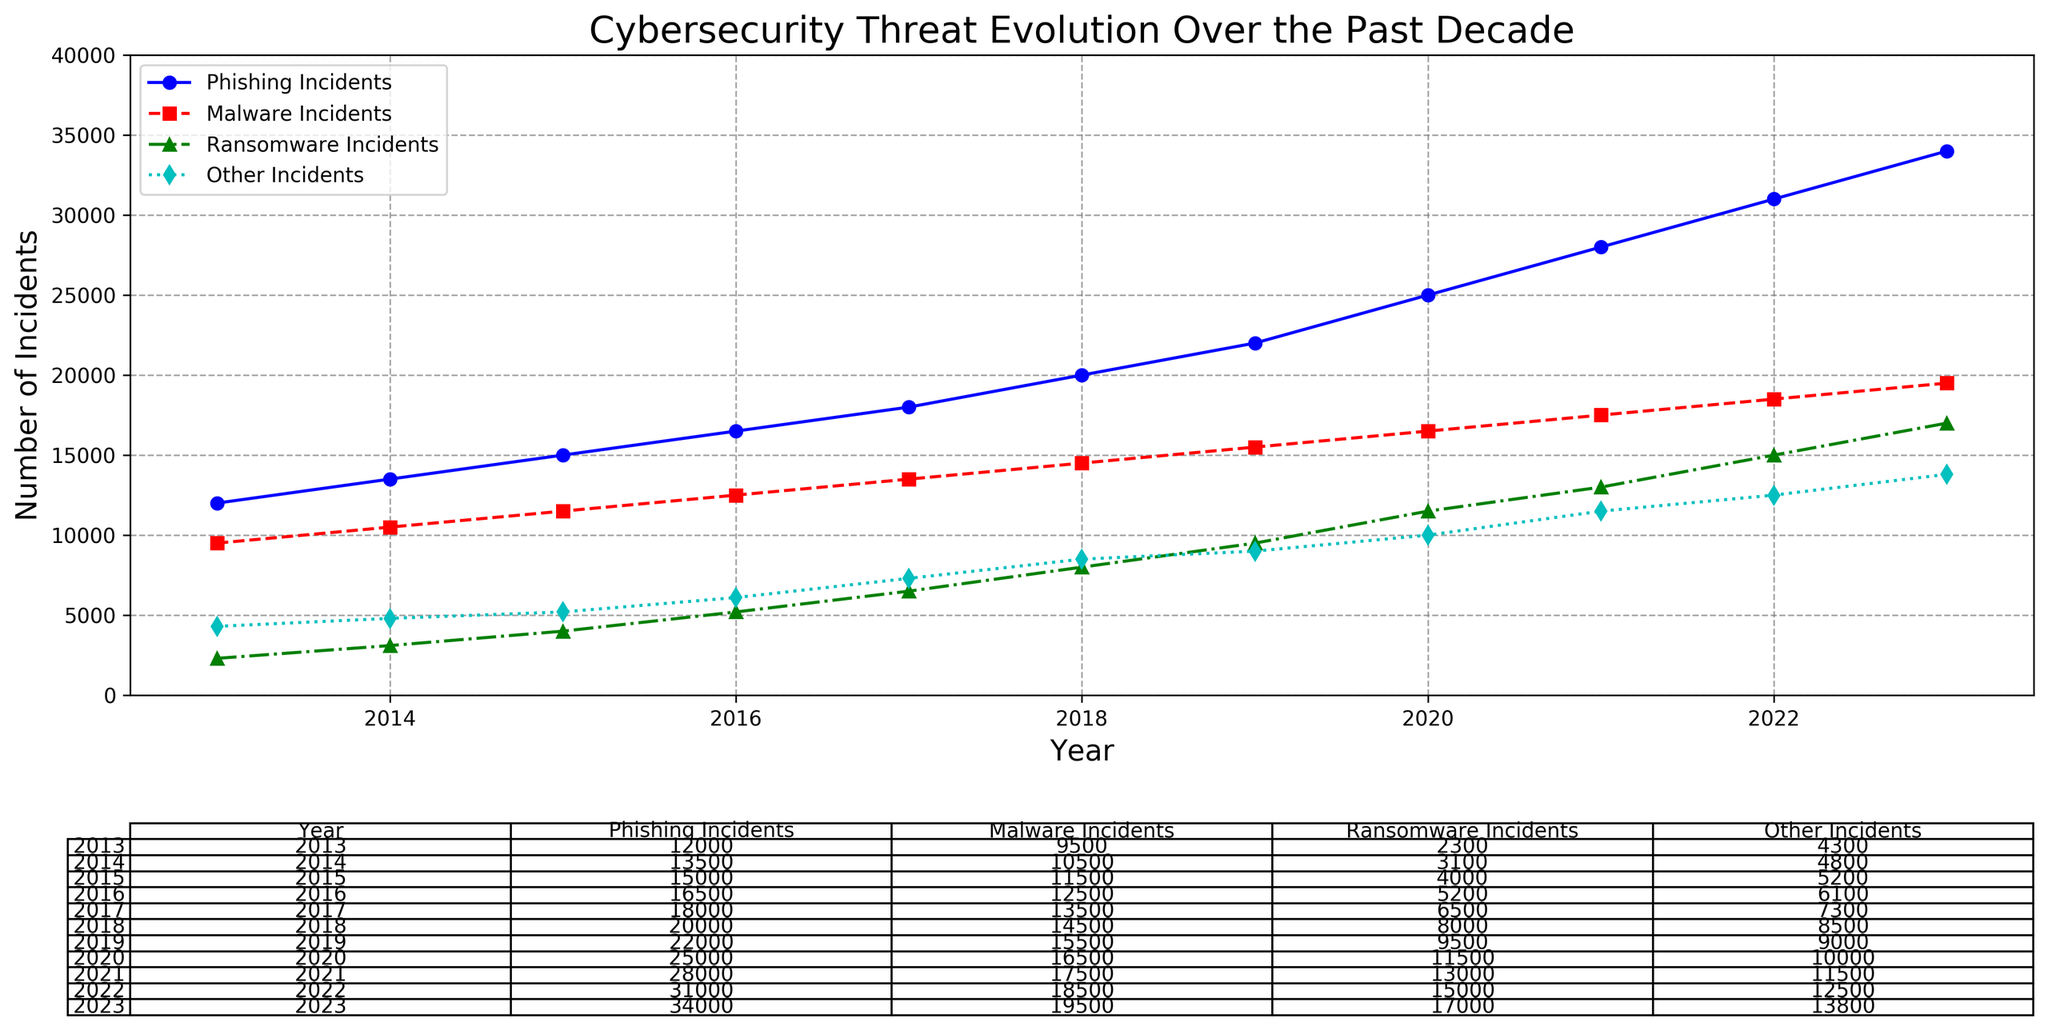What was the total number of cybersecurity incidents in 2016? Look at the values for Phishing, Malware, Ransomware, and Other Incidents in 2016. Sum them: 16500 (Phishing) + 12500 (Malware) + 5200 (Ransomware) + 6100 (Other) = 40300.
Answer: 40300 Which year had the highest number of Ransomware incidents? Identify the year with the maximum value in the Ransomware Incidents series. The maximum value 17000 occurs in 2023.
Answer: 2023 By how much did Phishing incidents increase from 2013 to 2023? Subtract the number of Phishing Incidents in 2013 from the number in 2023: 34000 (2023) - 12000 (2013) = 22000.
Answer: 22000 Compare the total number of incidents for Ransomware and Other incidents in 2020. Which was greater and by how much? Look at the values for Ransomware and Other incidents in 2020. Subtract the smaller number (Other) from the larger number (Ransomware): 11500 - 10000 = 1500. Ransomware was greater.
Answer: Ransomware, 1500 What is the average number of Malware Incidents from 2013 to 2023? Sum the Malware incidents from each year and divide by the number of years (11): (9500 + 10500 + 11500 + 12500 + 13500 + 14500 + 15500 + 16500 + 17500 + 18500 + 19500) / 11 = 14100.
Answer: 14100 Which type of incident had the most significant increase from 2013 to 2023? Calculate the difference for each incident type from 2013 to 2023: Phishing: 34000 - 12000 = 22000, Malware: 19500 - 9500 = 10000, Ransomware: 17000 - 2300 = 14700, Other: 13800 - 4300 = 9500. Phishing had the most significant increase.
Answer: Phishing In which year did Malware incidents surpass 15000 for the first time? Find the first year where the Malware Incidents value exceeds 15000. This occurred in 2019.
Answer: 2019 How did the number of Other incidents change from 2018 to 2019? Subtract the value for Other incidents in 2018 from the value in 2019: 9000 - 8500 = 500.
Answer: Increase by 500 By what percentage did the total number of incidents increase from 2013 to 2023? Calculate the total number of incidents for 2013 and 2023, then compute the percentage increase: 
Total for 2013 = 28100, Total for 2023 = 84300. Percentage increase = ((84300 - 28100) / 28100) * 100 ≈ 200.71%.
Answer: 200.71% Which year saw the highest overall increase in total cybersecurity incidents compared to the previous year? Calculate the increase for each pair of consecutive years and find the maximum: 
2014: (31900-28100)=3800, 2015: (35700-31900)=3800, 2016: (40300-35700)=4600, 2017: (45300-40300)=5000, 2018: (51000-45300)=5700, 2019: (56000-51000)=5000, 2020: (63000-56000)=7000, 2021: (70000-63000)=7000, 2022: (87500-70000)=9500, 2023: (84300-87500)=6800. The highest increase occurred in 2022.
Answer: 2022 